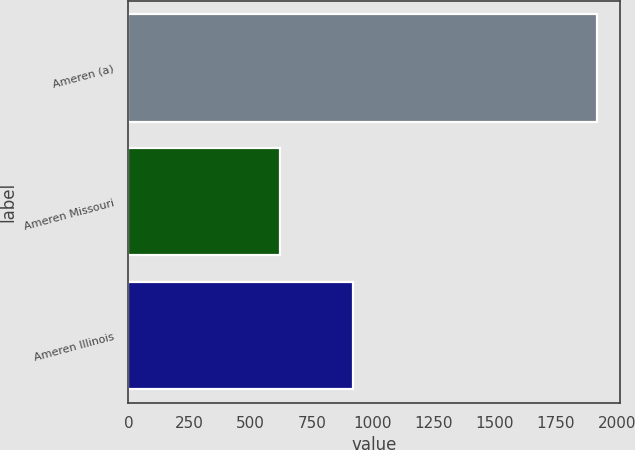<chart> <loc_0><loc_0><loc_500><loc_500><bar_chart><fcel>Ameren (a)<fcel>Ameren Missouri<fcel>Ameren Illinois<nl><fcel>1917<fcel>622<fcel>918<nl></chart> 